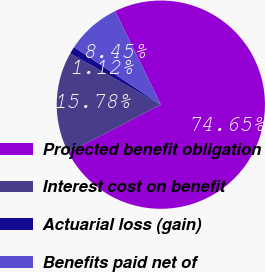<chart> <loc_0><loc_0><loc_500><loc_500><pie_chart><fcel>Projected benefit obligation<fcel>Interest cost on benefit<fcel>Actuarial loss (gain)<fcel>Benefits paid net of<nl><fcel>74.65%<fcel>15.78%<fcel>1.12%<fcel>8.45%<nl></chart> 